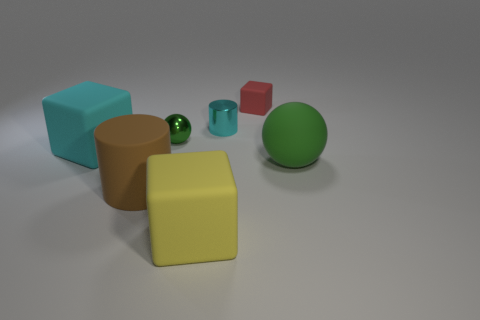Imagine these objects represent elements of a story. Could you craft a brief narrative involving them? Certainly! In a quiet, unassuming corner of a distant gallery, these five objects come to life at closing time. The cyan cube is the wise elder of the group, sharing tales of the ages. The brown and teal cylinders are the dynamic duo, always spinning around in dance, while the shy red cube watches quietly from its corner. The green sphere, full of wanderlust, dreams of rolling off to explore the world outside the gallery walls. Each night they converse and dream until the dawn returns them to stillness. 